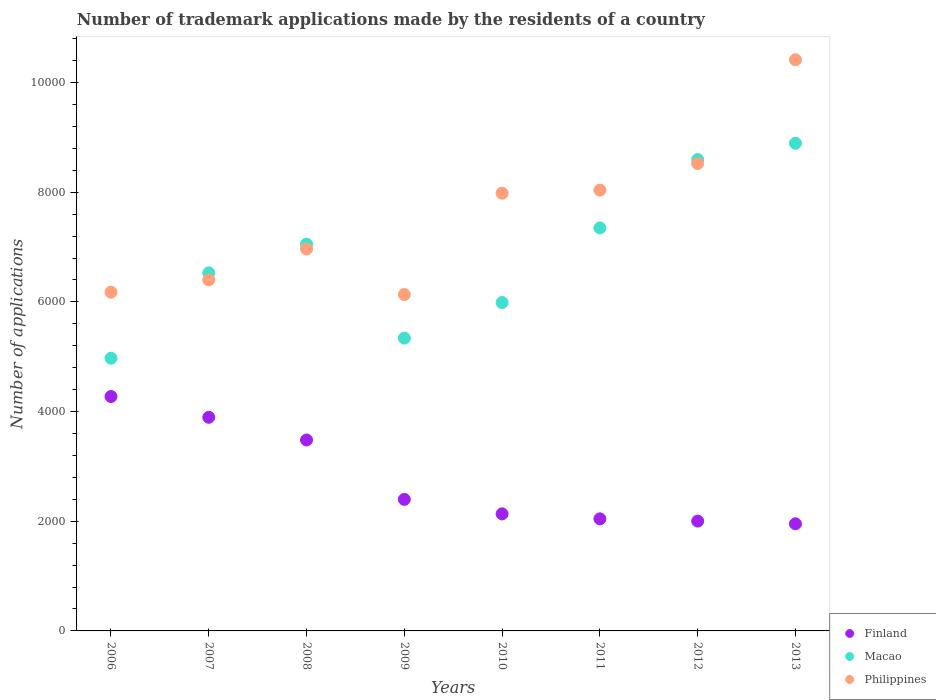Is the number of dotlines equal to the number of legend labels?
Offer a terse response. Yes. What is the number of trademark applications made by the residents in Finland in 2012?
Your response must be concise. 2003. Across all years, what is the maximum number of trademark applications made by the residents in Philippines?
Make the answer very short. 1.04e+04. Across all years, what is the minimum number of trademark applications made by the residents in Philippines?
Your answer should be very brief. 6135. What is the total number of trademark applications made by the residents in Finland in the graph?
Give a very brief answer. 2.22e+04. What is the difference between the number of trademark applications made by the residents in Macao in 2007 and that in 2010?
Give a very brief answer. 540. What is the difference between the number of trademark applications made by the residents in Philippines in 2008 and the number of trademark applications made by the residents in Macao in 2012?
Give a very brief answer. -1631. What is the average number of trademark applications made by the residents in Macao per year?
Provide a short and direct response. 6840.5. In the year 2007, what is the difference between the number of trademark applications made by the residents in Macao and number of trademark applications made by the residents in Philippines?
Make the answer very short. 127. In how many years, is the number of trademark applications made by the residents in Macao greater than 4800?
Your answer should be very brief. 8. What is the ratio of the number of trademark applications made by the residents in Finland in 2007 to that in 2012?
Make the answer very short. 1.95. Is the number of trademark applications made by the residents in Finland in 2006 less than that in 2009?
Provide a succinct answer. No. Is the difference between the number of trademark applications made by the residents in Macao in 2006 and 2012 greater than the difference between the number of trademark applications made by the residents in Philippines in 2006 and 2012?
Your answer should be compact. No. What is the difference between the highest and the second highest number of trademark applications made by the residents in Finland?
Ensure brevity in your answer.  379. What is the difference between the highest and the lowest number of trademark applications made by the residents in Finland?
Offer a terse response. 2321. In how many years, is the number of trademark applications made by the residents in Macao greater than the average number of trademark applications made by the residents in Macao taken over all years?
Ensure brevity in your answer.  4. Is it the case that in every year, the sum of the number of trademark applications made by the residents in Macao and number of trademark applications made by the residents in Philippines  is greater than the number of trademark applications made by the residents in Finland?
Your response must be concise. Yes. Does the number of trademark applications made by the residents in Philippines monotonically increase over the years?
Ensure brevity in your answer.  No. Is the number of trademark applications made by the residents in Philippines strictly less than the number of trademark applications made by the residents in Macao over the years?
Your response must be concise. No. How many dotlines are there?
Your answer should be very brief. 3. How many years are there in the graph?
Make the answer very short. 8. What is the difference between two consecutive major ticks on the Y-axis?
Offer a terse response. 2000. Are the values on the major ticks of Y-axis written in scientific E-notation?
Your answer should be very brief. No. How many legend labels are there?
Offer a terse response. 3. What is the title of the graph?
Offer a very short reply. Number of trademark applications made by the residents of a country. What is the label or title of the Y-axis?
Offer a terse response. Number of applications. What is the Number of applications of Finland in 2006?
Offer a terse response. 4275. What is the Number of applications in Macao in 2006?
Provide a succinct answer. 4973. What is the Number of applications of Philippines in 2006?
Provide a short and direct response. 6177. What is the Number of applications in Finland in 2007?
Your answer should be very brief. 3896. What is the Number of applications of Macao in 2007?
Keep it short and to the point. 6529. What is the Number of applications in Philippines in 2007?
Offer a very short reply. 6402. What is the Number of applications of Finland in 2008?
Provide a short and direct response. 3482. What is the Number of applications of Macao in 2008?
Keep it short and to the point. 7054. What is the Number of applications of Philippines in 2008?
Offer a terse response. 6965. What is the Number of applications of Finland in 2009?
Offer a terse response. 2399. What is the Number of applications of Macao in 2009?
Give a very brief answer. 5340. What is the Number of applications of Philippines in 2009?
Your response must be concise. 6135. What is the Number of applications in Finland in 2010?
Keep it short and to the point. 2135. What is the Number of applications in Macao in 2010?
Offer a terse response. 5989. What is the Number of applications in Philippines in 2010?
Give a very brief answer. 7983. What is the Number of applications in Finland in 2011?
Offer a terse response. 2044. What is the Number of applications of Macao in 2011?
Your response must be concise. 7350. What is the Number of applications in Philippines in 2011?
Ensure brevity in your answer.  8039. What is the Number of applications in Finland in 2012?
Provide a short and direct response. 2003. What is the Number of applications of Macao in 2012?
Your answer should be compact. 8596. What is the Number of applications in Philippines in 2012?
Offer a terse response. 8523. What is the Number of applications of Finland in 2013?
Provide a short and direct response. 1954. What is the Number of applications in Macao in 2013?
Your answer should be very brief. 8893. What is the Number of applications in Philippines in 2013?
Your answer should be very brief. 1.04e+04. Across all years, what is the maximum Number of applications in Finland?
Make the answer very short. 4275. Across all years, what is the maximum Number of applications in Macao?
Offer a terse response. 8893. Across all years, what is the maximum Number of applications in Philippines?
Make the answer very short. 1.04e+04. Across all years, what is the minimum Number of applications in Finland?
Give a very brief answer. 1954. Across all years, what is the minimum Number of applications in Macao?
Offer a terse response. 4973. Across all years, what is the minimum Number of applications of Philippines?
Ensure brevity in your answer.  6135. What is the total Number of applications in Finland in the graph?
Give a very brief answer. 2.22e+04. What is the total Number of applications in Macao in the graph?
Offer a terse response. 5.47e+04. What is the total Number of applications in Philippines in the graph?
Provide a short and direct response. 6.06e+04. What is the difference between the Number of applications of Finland in 2006 and that in 2007?
Keep it short and to the point. 379. What is the difference between the Number of applications of Macao in 2006 and that in 2007?
Make the answer very short. -1556. What is the difference between the Number of applications in Philippines in 2006 and that in 2007?
Offer a very short reply. -225. What is the difference between the Number of applications of Finland in 2006 and that in 2008?
Keep it short and to the point. 793. What is the difference between the Number of applications of Macao in 2006 and that in 2008?
Ensure brevity in your answer.  -2081. What is the difference between the Number of applications in Philippines in 2006 and that in 2008?
Keep it short and to the point. -788. What is the difference between the Number of applications of Finland in 2006 and that in 2009?
Keep it short and to the point. 1876. What is the difference between the Number of applications of Macao in 2006 and that in 2009?
Offer a terse response. -367. What is the difference between the Number of applications in Philippines in 2006 and that in 2009?
Ensure brevity in your answer.  42. What is the difference between the Number of applications of Finland in 2006 and that in 2010?
Your response must be concise. 2140. What is the difference between the Number of applications of Macao in 2006 and that in 2010?
Your answer should be compact. -1016. What is the difference between the Number of applications of Philippines in 2006 and that in 2010?
Make the answer very short. -1806. What is the difference between the Number of applications of Finland in 2006 and that in 2011?
Your response must be concise. 2231. What is the difference between the Number of applications of Macao in 2006 and that in 2011?
Ensure brevity in your answer.  -2377. What is the difference between the Number of applications of Philippines in 2006 and that in 2011?
Provide a succinct answer. -1862. What is the difference between the Number of applications in Finland in 2006 and that in 2012?
Provide a succinct answer. 2272. What is the difference between the Number of applications in Macao in 2006 and that in 2012?
Your answer should be compact. -3623. What is the difference between the Number of applications in Philippines in 2006 and that in 2012?
Your answer should be very brief. -2346. What is the difference between the Number of applications of Finland in 2006 and that in 2013?
Keep it short and to the point. 2321. What is the difference between the Number of applications of Macao in 2006 and that in 2013?
Your answer should be very brief. -3920. What is the difference between the Number of applications of Philippines in 2006 and that in 2013?
Give a very brief answer. -4239. What is the difference between the Number of applications of Finland in 2007 and that in 2008?
Ensure brevity in your answer.  414. What is the difference between the Number of applications in Macao in 2007 and that in 2008?
Your response must be concise. -525. What is the difference between the Number of applications of Philippines in 2007 and that in 2008?
Offer a very short reply. -563. What is the difference between the Number of applications of Finland in 2007 and that in 2009?
Provide a short and direct response. 1497. What is the difference between the Number of applications in Macao in 2007 and that in 2009?
Make the answer very short. 1189. What is the difference between the Number of applications of Philippines in 2007 and that in 2009?
Offer a terse response. 267. What is the difference between the Number of applications in Finland in 2007 and that in 2010?
Provide a short and direct response. 1761. What is the difference between the Number of applications of Macao in 2007 and that in 2010?
Your answer should be compact. 540. What is the difference between the Number of applications of Philippines in 2007 and that in 2010?
Your answer should be compact. -1581. What is the difference between the Number of applications of Finland in 2007 and that in 2011?
Your response must be concise. 1852. What is the difference between the Number of applications in Macao in 2007 and that in 2011?
Give a very brief answer. -821. What is the difference between the Number of applications of Philippines in 2007 and that in 2011?
Give a very brief answer. -1637. What is the difference between the Number of applications of Finland in 2007 and that in 2012?
Offer a terse response. 1893. What is the difference between the Number of applications in Macao in 2007 and that in 2012?
Offer a terse response. -2067. What is the difference between the Number of applications of Philippines in 2007 and that in 2012?
Offer a terse response. -2121. What is the difference between the Number of applications of Finland in 2007 and that in 2013?
Your answer should be compact. 1942. What is the difference between the Number of applications of Macao in 2007 and that in 2013?
Your answer should be compact. -2364. What is the difference between the Number of applications in Philippines in 2007 and that in 2013?
Offer a terse response. -4014. What is the difference between the Number of applications of Finland in 2008 and that in 2009?
Your answer should be compact. 1083. What is the difference between the Number of applications in Macao in 2008 and that in 2009?
Offer a very short reply. 1714. What is the difference between the Number of applications in Philippines in 2008 and that in 2009?
Make the answer very short. 830. What is the difference between the Number of applications of Finland in 2008 and that in 2010?
Offer a very short reply. 1347. What is the difference between the Number of applications of Macao in 2008 and that in 2010?
Keep it short and to the point. 1065. What is the difference between the Number of applications of Philippines in 2008 and that in 2010?
Your answer should be very brief. -1018. What is the difference between the Number of applications in Finland in 2008 and that in 2011?
Provide a short and direct response. 1438. What is the difference between the Number of applications of Macao in 2008 and that in 2011?
Provide a short and direct response. -296. What is the difference between the Number of applications in Philippines in 2008 and that in 2011?
Provide a succinct answer. -1074. What is the difference between the Number of applications in Finland in 2008 and that in 2012?
Your response must be concise. 1479. What is the difference between the Number of applications of Macao in 2008 and that in 2012?
Provide a short and direct response. -1542. What is the difference between the Number of applications of Philippines in 2008 and that in 2012?
Provide a short and direct response. -1558. What is the difference between the Number of applications of Finland in 2008 and that in 2013?
Offer a terse response. 1528. What is the difference between the Number of applications in Macao in 2008 and that in 2013?
Your answer should be compact. -1839. What is the difference between the Number of applications of Philippines in 2008 and that in 2013?
Offer a very short reply. -3451. What is the difference between the Number of applications in Finland in 2009 and that in 2010?
Provide a succinct answer. 264. What is the difference between the Number of applications in Macao in 2009 and that in 2010?
Provide a succinct answer. -649. What is the difference between the Number of applications of Philippines in 2009 and that in 2010?
Offer a very short reply. -1848. What is the difference between the Number of applications in Finland in 2009 and that in 2011?
Provide a short and direct response. 355. What is the difference between the Number of applications in Macao in 2009 and that in 2011?
Your response must be concise. -2010. What is the difference between the Number of applications of Philippines in 2009 and that in 2011?
Offer a terse response. -1904. What is the difference between the Number of applications in Finland in 2009 and that in 2012?
Offer a very short reply. 396. What is the difference between the Number of applications in Macao in 2009 and that in 2012?
Provide a short and direct response. -3256. What is the difference between the Number of applications of Philippines in 2009 and that in 2012?
Keep it short and to the point. -2388. What is the difference between the Number of applications in Finland in 2009 and that in 2013?
Your answer should be very brief. 445. What is the difference between the Number of applications in Macao in 2009 and that in 2013?
Your answer should be compact. -3553. What is the difference between the Number of applications in Philippines in 2009 and that in 2013?
Provide a succinct answer. -4281. What is the difference between the Number of applications in Finland in 2010 and that in 2011?
Your answer should be compact. 91. What is the difference between the Number of applications in Macao in 2010 and that in 2011?
Offer a terse response. -1361. What is the difference between the Number of applications of Philippines in 2010 and that in 2011?
Provide a succinct answer. -56. What is the difference between the Number of applications in Finland in 2010 and that in 2012?
Ensure brevity in your answer.  132. What is the difference between the Number of applications in Macao in 2010 and that in 2012?
Give a very brief answer. -2607. What is the difference between the Number of applications in Philippines in 2010 and that in 2012?
Provide a short and direct response. -540. What is the difference between the Number of applications of Finland in 2010 and that in 2013?
Your response must be concise. 181. What is the difference between the Number of applications in Macao in 2010 and that in 2013?
Give a very brief answer. -2904. What is the difference between the Number of applications in Philippines in 2010 and that in 2013?
Make the answer very short. -2433. What is the difference between the Number of applications of Macao in 2011 and that in 2012?
Give a very brief answer. -1246. What is the difference between the Number of applications of Philippines in 2011 and that in 2012?
Your answer should be very brief. -484. What is the difference between the Number of applications in Macao in 2011 and that in 2013?
Provide a succinct answer. -1543. What is the difference between the Number of applications in Philippines in 2011 and that in 2013?
Give a very brief answer. -2377. What is the difference between the Number of applications of Finland in 2012 and that in 2013?
Your answer should be compact. 49. What is the difference between the Number of applications in Macao in 2012 and that in 2013?
Your answer should be compact. -297. What is the difference between the Number of applications of Philippines in 2012 and that in 2013?
Ensure brevity in your answer.  -1893. What is the difference between the Number of applications of Finland in 2006 and the Number of applications of Macao in 2007?
Make the answer very short. -2254. What is the difference between the Number of applications in Finland in 2006 and the Number of applications in Philippines in 2007?
Offer a terse response. -2127. What is the difference between the Number of applications of Macao in 2006 and the Number of applications of Philippines in 2007?
Provide a succinct answer. -1429. What is the difference between the Number of applications of Finland in 2006 and the Number of applications of Macao in 2008?
Offer a terse response. -2779. What is the difference between the Number of applications of Finland in 2006 and the Number of applications of Philippines in 2008?
Make the answer very short. -2690. What is the difference between the Number of applications of Macao in 2006 and the Number of applications of Philippines in 2008?
Your answer should be compact. -1992. What is the difference between the Number of applications of Finland in 2006 and the Number of applications of Macao in 2009?
Offer a terse response. -1065. What is the difference between the Number of applications of Finland in 2006 and the Number of applications of Philippines in 2009?
Provide a short and direct response. -1860. What is the difference between the Number of applications in Macao in 2006 and the Number of applications in Philippines in 2009?
Provide a short and direct response. -1162. What is the difference between the Number of applications in Finland in 2006 and the Number of applications in Macao in 2010?
Provide a short and direct response. -1714. What is the difference between the Number of applications of Finland in 2006 and the Number of applications of Philippines in 2010?
Provide a succinct answer. -3708. What is the difference between the Number of applications of Macao in 2006 and the Number of applications of Philippines in 2010?
Ensure brevity in your answer.  -3010. What is the difference between the Number of applications of Finland in 2006 and the Number of applications of Macao in 2011?
Provide a succinct answer. -3075. What is the difference between the Number of applications in Finland in 2006 and the Number of applications in Philippines in 2011?
Provide a short and direct response. -3764. What is the difference between the Number of applications of Macao in 2006 and the Number of applications of Philippines in 2011?
Give a very brief answer. -3066. What is the difference between the Number of applications in Finland in 2006 and the Number of applications in Macao in 2012?
Your answer should be compact. -4321. What is the difference between the Number of applications of Finland in 2006 and the Number of applications of Philippines in 2012?
Ensure brevity in your answer.  -4248. What is the difference between the Number of applications of Macao in 2006 and the Number of applications of Philippines in 2012?
Provide a short and direct response. -3550. What is the difference between the Number of applications of Finland in 2006 and the Number of applications of Macao in 2013?
Your answer should be compact. -4618. What is the difference between the Number of applications of Finland in 2006 and the Number of applications of Philippines in 2013?
Give a very brief answer. -6141. What is the difference between the Number of applications of Macao in 2006 and the Number of applications of Philippines in 2013?
Your response must be concise. -5443. What is the difference between the Number of applications of Finland in 2007 and the Number of applications of Macao in 2008?
Your answer should be very brief. -3158. What is the difference between the Number of applications of Finland in 2007 and the Number of applications of Philippines in 2008?
Your answer should be compact. -3069. What is the difference between the Number of applications of Macao in 2007 and the Number of applications of Philippines in 2008?
Your answer should be compact. -436. What is the difference between the Number of applications in Finland in 2007 and the Number of applications in Macao in 2009?
Offer a very short reply. -1444. What is the difference between the Number of applications in Finland in 2007 and the Number of applications in Philippines in 2009?
Your answer should be very brief. -2239. What is the difference between the Number of applications in Macao in 2007 and the Number of applications in Philippines in 2009?
Your response must be concise. 394. What is the difference between the Number of applications of Finland in 2007 and the Number of applications of Macao in 2010?
Your response must be concise. -2093. What is the difference between the Number of applications in Finland in 2007 and the Number of applications in Philippines in 2010?
Ensure brevity in your answer.  -4087. What is the difference between the Number of applications of Macao in 2007 and the Number of applications of Philippines in 2010?
Provide a succinct answer. -1454. What is the difference between the Number of applications in Finland in 2007 and the Number of applications in Macao in 2011?
Ensure brevity in your answer.  -3454. What is the difference between the Number of applications in Finland in 2007 and the Number of applications in Philippines in 2011?
Your answer should be very brief. -4143. What is the difference between the Number of applications of Macao in 2007 and the Number of applications of Philippines in 2011?
Your answer should be very brief. -1510. What is the difference between the Number of applications of Finland in 2007 and the Number of applications of Macao in 2012?
Make the answer very short. -4700. What is the difference between the Number of applications of Finland in 2007 and the Number of applications of Philippines in 2012?
Offer a terse response. -4627. What is the difference between the Number of applications in Macao in 2007 and the Number of applications in Philippines in 2012?
Your answer should be very brief. -1994. What is the difference between the Number of applications of Finland in 2007 and the Number of applications of Macao in 2013?
Make the answer very short. -4997. What is the difference between the Number of applications of Finland in 2007 and the Number of applications of Philippines in 2013?
Ensure brevity in your answer.  -6520. What is the difference between the Number of applications in Macao in 2007 and the Number of applications in Philippines in 2013?
Your response must be concise. -3887. What is the difference between the Number of applications in Finland in 2008 and the Number of applications in Macao in 2009?
Your answer should be very brief. -1858. What is the difference between the Number of applications in Finland in 2008 and the Number of applications in Philippines in 2009?
Your answer should be very brief. -2653. What is the difference between the Number of applications in Macao in 2008 and the Number of applications in Philippines in 2009?
Offer a terse response. 919. What is the difference between the Number of applications in Finland in 2008 and the Number of applications in Macao in 2010?
Give a very brief answer. -2507. What is the difference between the Number of applications of Finland in 2008 and the Number of applications of Philippines in 2010?
Give a very brief answer. -4501. What is the difference between the Number of applications in Macao in 2008 and the Number of applications in Philippines in 2010?
Give a very brief answer. -929. What is the difference between the Number of applications in Finland in 2008 and the Number of applications in Macao in 2011?
Your answer should be very brief. -3868. What is the difference between the Number of applications in Finland in 2008 and the Number of applications in Philippines in 2011?
Make the answer very short. -4557. What is the difference between the Number of applications in Macao in 2008 and the Number of applications in Philippines in 2011?
Offer a very short reply. -985. What is the difference between the Number of applications in Finland in 2008 and the Number of applications in Macao in 2012?
Give a very brief answer. -5114. What is the difference between the Number of applications of Finland in 2008 and the Number of applications of Philippines in 2012?
Ensure brevity in your answer.  -5041. What is the difference between the Number of applications in Macao in 2008 and the Number of applications in Philippines in 2012?
Make the answer very short. -1469. What is the difference between the Number of applications in Finland in 2008 and the Number of applications in Macao in 2013?
Provide a short and direct response. -5411. What is the difference between the Number of applications in Finland in 2008 and the Number of applications in Philippines in 2013?
Keep it short and to the point. -6934. What is the difference between the Number of applications of Macao in 2008 and the Number of applications of Philippines in 2013?
Make the answer very short. -3362. What is the difference between the Number of applications in Finland in 2009 and the Number of applications in Macao in 2010?
Your answer should be very brief. -3590. What is the difference between the Number of applications in Finland in 2009 and the Number of applications in Philippines in 2010?
Keep it short and to the point. -5584. What is the difference between the Number of applications of Macao in 2009 and the Number of applications of Philippines in 2010?
Keep it short and to the point. -2643. What is the difference between the Number of applications in Finland in 2009 and the Number of applications in Macao in 2011?
Provide a succinct answer. -4951. What is the difference between the Number of applications of Finland in 2009 and the Number of applications of Philippines in 2011?
Provide a succinct answer. -5640. What is the difference between the Number of applications of Macao in 2009 and the Number of applications of Philippines in 2011?
Ensure brevity in your answer.  -2699. What is the difference between the Number of applications of Finland in 2009 and the Number of applications of Macao in 2012?
Offer a very short reply. -6197. What is the difference between the Number of applications in Finland in 2009 and the Number of applications in Philippines in 2012?
Ensure brevity in your answer.  -6124. What is the difference between the Number of applications of Macao in 2009 and the Number of applications of Philippines in 2012?
Make the answer very short. -3183. What is the difference between the Number of applications in Finland in 2009 and the Number of applications in Macao in 2013?
Provide a short and direct response. -6494. What is the difference between the Number of applications in Finland in 2009 and the Number of applications in Philippines in 2013?
Provide a succinct answer. -8017. What is the difference between the Number of applications of Macao in 2009 and the Number of applications of Philippines in 2013?
Offer a terse response. -5076. What is the difference between the Number of applications of Finland in 2010 and the Number of applications of Macao in 2011?
Provide a succinct answer. -5215. What is the difference between the Number of applications in Finland in 2010 and the Number of applications in Philippines in 2011?
Make the answer very short. -5904. What is the difference between the Number of applications in Macao in 2010 and the Number of applications in Philippines in 2011?
Make the answer very short. -2050. What is the difference between the Number of applications of Finland in 2010 and the Number of applications of Macao in 2012?
Ensure brevity in your answer.  -6461. What is the difference between the Number of applications of Finland in 2010 and the Number of applications of Philippines in 2012?
Your response must be concise. -6388. What is the difference between the Number of applications of Macao in 2010 and the Number of applications of Philippines in 2012?
Ensure brevity in your answer.  -2534. What is the difference between the Number of applications in Finland in 2010 and the Number of applications in Macao in 2013?
Keep it short and to the point. -6758. What is the difference between the Number of applications of Finland in 2010 and the Number of applications of Philippines in 2013?
Make the answer very short. -8281. What is the difference between the Number of applications in Macao in 2010 and the Number of applications in Philippines in 2013?
Provide a short and direct response. -4427. What is the difference between the Number of applications in Finland in 2011 and the Number of applications in Macao in 2012?
Provide a succinct answer. -6552. What is the difference between the Number of applications in Finland in 2011 and the Number of applications in Philippines in 2012?
Ensure brevity in your answer.  -6479. What is the difference between the Number of applications in Macao in 2011 and the Number of applications in Philippines in 2012?
Ensure brevity in your answer.  -1173. What is the difference between the Number of applications in Finland in 2011 and the Number of applications in Macao in 2013?
Your response must be concise. -6849. What is the difference between the Number of applications in Finland in 2011 and the Number of applications in Philippines in 2013?
Keep it short and to the point. -8372. What is the difference between the Number of applications in Macao in 2011 and the Number of applications in Philippines in 2013?
Your answer should be very brief. -3066. What is the difference between the Number of applications of Finland in 2012 and the Number of applications of Macao in 2013?
Your answer should be very brief. -6890. What is the difference between the Number of applications of Finland in 2012 and the Number of applications of Philippines in 2013?
Your response must be concise. -8413. What is the difference between the Number of applications in Macao in 2012 and the Number of applications in Philippines in 2013?
Make the answer very short. -1820. What is the average Number of applications of Finland per year?
Keep it short and to the point. 2773.5. What is the average Number of applications of Macao per year?
Your answer should be compact. 6840.5. What is the average Number of applications of Philippines per year?
Offer a very short reply. 7580. In the year 2006, what is the difference between the Number of applications in Finland and Number of applications in Macao?
Keep it short and to the point. -698. In the year 2006, what is the difference between the Number of applications of Finland and Number of applications of Philippines?
Your answer should be very brief. -1902. In the year 2006, what is the difference between the Number of applications of Macao and Number of applications of Philippines?
Offer a terse response. -1204. In the year 2007, what is the difference between the Number of applications of Finland and Number of applications of Macao?
Give a very brief answer. -2633. In the year 2007, what is the difference between the Number of applications in Finland and Number of applications in Philippines?
Make the answer very short. -2506. In the year 2007, what is the difference between the Number of applications in Macao and Number of applications in Philippines?
Make the answer very short. 127. In the year 2008, what is the difference between the Number of applications of Finland and Number of applications of Macao?
Your answer should be compact. -3572. In the year 2008, what is the difference between the Number of applications in Finland and Number of applications in Philippines?
Offer a terse response. -3483. In the year 2008, what is the difference between the Number of applications in Macao and Number of applications in Philippines?
Provide a succinct answer. 89. In the year 2009, what is the difference between the Number of applications in Finland and Number of applications in Macao?
Your response must be concise. -2941. In the year 2009, what is the difference between the Number of applications in Finland and Number of applications in Philippines?
Offer a terse response. -3736. In the year 2009, what is the difference between the Number of applications of Macao and Number of applications of Philippines?
Offer a terse response. -795. In the year 2010, what is the difference between the Number of applications of Finland and Number of applications of Macao?
Provide a short and direct response. -3854. In the year 2010, what is the difference between the Number of applications in Finland and Number of applications in Philippines?
Offer a terse response. -5848. In the year 2010, what is the difference between the Number of applications in Macao and Number of applications in Philippines?
Ensure brevity in your answer.  -1994. In the year 2011, what is the difference between the Number of applications in Finland and Number of applications in Macao?
Your response must be concise. -5306. In the year 2011, what is the difference between the Number of applications of Finland and Number of applications of Philippines?
Provide a succinct answer. -5995. In the year 2011, what is the difference between the Number of applications in Macao and Number of applications in Philippines?
Ensure brevity in your answer.  -689. In the year 2012, what is the difference between the Number of applications of Finland and Number of applications of Macao?
Keep it short and to the point. -6593. In the year 2012, what is the difference between the Number of applications in Finland and Number of applications in Philippines?
Provide a succinct answer. -6520. In the year 2013, what is the difference between the Number of applications in Finland and Number of applications in Macao?
Ensure brevity in your answer.  -6939. In the year 2013, what is the difference between the Number of applications in Finland and Number of applications in Philippines?
Your response must be concise. -8462. In the year 2013, what is the difference between the Number of applications in Macao and Number of applications in Philippines?
Your response must be concise. -1523. What is the ratio of the Number of applications of Finland in 2006 to that in 2007?
Make the answer very short. 1.1. What is the ratio of the Number of applications in Macao in 2006 to that in 2007?
Ensure brevity in your answer.  0.76. What is the ratio of the Number of applications in Philippines in 2006 to that in 2007?
Your response must be concise. 0.96. What is the ratio of the Number of applications of Finland in 2006 to that in 2008?
Offer a very short reply. 1.23. What is the ratio of the Number of applications of Macao in 2006 to that in 2008?
Keep it short and to the point. 0.7. What is the ratio of the Number of applications of Philippines in 2006 to that in 2008?
Give a very brief answer. 0.89. What is the ratio of the Number of applications in Finland in 2006 to that in 2009?
Make the answer very short. 1.78. What is the ratio of the Number of applications of Macao in 2006 to that in 2009?
Your answer should be compact. 0.93. What is the ratio of the Number of applications of Philippines in 2006 to that in 2009?
Make the answer very short. 1.01. What is the ratio of the Number of applications in Finland in 2006 to that in 2010?
Your answer should be compact. 2. What is the ratio of the Number of applications in Macao in 2006 to that in 2010?
Give a very brief answer. 0.83. What is the ratio of the Number of applications of Philippines in 2006 to that in 2010?
Your answer should be very brief. 0.77. What is the ratio of the Number of applications in Finland in 2006 to that in 2011?
Your answer should be compact. 2.09. What is the ratio of the Number of applications of Macao in 2006 to that in 2011?
Provide a short and direct response. 0.68. What is the ratio of the Number of applications in Philippines in 2006 to that in 2011?
Give a very brief answer. 0.77. What is the ratio of the Number of applications in Finland in 2006 to that in 2012?
Provide a short and direct response. 2.13. What is the ratio of the Number of applications of Macao in 2006 to that in 2012?
Ensure brevity in your answer.  0.58. What is the ratio of the Number of applications of Philippines in 2006 to that in 2012?
Provide a succinct answer. 0.72. What is the ratio of the Number of applications of Finland in 2006 to that in 2013?
Your answer should be very brief. 2.19. What is the ratio of the Number of applications in Macao in 2006 to that in 2013?
Offer a very short reply. 0.56. What is the ratio of the Number of applications of Philippines in 2006 to that in 2013?
Your response must be concise. 0.59. What is the ratio of the Number of applications in Finland in 2007 to that in 2008?
Keep it short and to the point. 1.12. What is the ratio of the Number of applications in Macao in 2007 to that in 2008?
Ensure brevity in your answer.  0.93. What is the ratio of the Number of applications of Philippines in 2007 to that in 2008?
Offer a very short reply. 0.92. What is the ratio of the Number of applications of Finland in 2007 to that in 2009?
Your answer should be very brief. 1.62. What is the ratio of the Number of applications in Macao in 2007 to that in 2009?
Your answer should be very brief. 1.22. What is the ratio of the Number of applications of Philippines in 2007 to that in 2009?
Make the answer very short. 1.04. What is the ratio of the Number of applications in Finland in 2007 to that in 2010?
Offer a very short reply. 1.82. What is the ratio of the Number of applications in Macao in 2007 to that in 2010?
Your response must be concise. 1.09. What is the ratio of the Number of applications of Philippines in 2007 to that in 2010?
Offer a terse response. 0.8. What is the ratio of the Number of applications of Finland in 2007 to that in 2011?
Offer a very short reply. 1.91. What is the ratio of the Number of applications of Macao in 2007 to that in 2011?
Give a very brief answer. 0.89. What is the ratio of the Number of applications in Philippines in 2007 to that in 2011?
Your answer should be very brief. 0.8. What is the ratio of the Number of applications of Finland in 2007 to that in 2012?
Provide a succinct answer. 1.95. What is the ratio of the Number of applications of Macao in 2007 to that in 2012?
Provide a short and direct response. 0.76. What is the ratio of the Number of applications of Philippines in 2007 to that in 2012?
Give a very brief answer. 0.75. What is the ratio of the Number of applications in Finland in 2007 to that in 2013?
Keep it short and to the point. 1.99. What is the ratio of the Number of applications in Macao in 2007 to that in 2013?
Ensure brevity in your answer.  0.73. What is the ratio of the Number of applications of Philippines in 2007 to that in 2013?
Give a very brief answer. 0.61. What is the ratio of the Number of applications in Finland in 2008 to that in 2009?
Keep it short and to the point. 1.45. What is the ratio of the Number of applications in Macao in 2008 to that in 2009?
Make the answer very short. 1.32. What is the ratio of the Number of applications in Philippines in 2008 to that in 2009?
Provide a short and direct response. 1.14. What is the ratio of the Number of applications in Finland in 2008 to that in 2010?
Give a very brief answer. 1.63. What is the ratio of the Number of applications in Macao in 2008 to that in 2010?
Provide a short and direct response. 1.18. What is the ratio of the Number of applications in Philippines in 2008 to that in 2010?
Make the answer very short. 0.87. What is the ratio of the Number of applications in Finland in 2008 to that in 2011?
Provide a succinct answer. 1.7. What is the ratio of the Number of applications of Macao in 2008 to that in 2011?
Give a very brief answer. 0.96. What is the ratio of the Number of applications in Philippines in 2008 to that in 2011?
Your answer should be very brief. 0.87. What is the ratio of the Number of applications in Finland in 2008 to that in 2012?
Your response must be concise. 1.74. What is the ratio of the Number of applications of Macao in 2008 to that in 2012?
Your response must be concise. 0.82. What is the ratio of the Number of applications in Philippines in 2008 to that in 2012?
Your answer should be compact. 0.82. What is the ratio of the Number of applications in Finland in 2008 to that in 2013?
Offer a very short reply. 1.78. What is the ratio of the Number of applications of Macao in 2008 to that in 2013?
Offer a terse response. 0.79. What is the ratio of the Number of applications in Philippines in 2008 to that in 2013?
Offer a terse response. 0.67. What is the ratio of the Number of applications in Finland in 2009 to that in 2010?
Provide a succinct answer. 1.12. What is the ratio of the Number of applications in Macao in 2009 to that in 2010?
Provide a short and direct response. 0.89. What is the ratio of the Number of applications in Philippines in 2009 to that in 2010?
Your answer should be compact. 0.77. What is the ratio of the Number of applications of Finland in 2009 to that in 2011?
Offer a terse response. 1.17. What is the ratio of the Number of applications in Macao in 2009 to that in 2011?
Offer a very short reply. 0.73. What is the ratio of the Number of applications of Philippines in 2009 to that in 2011?
Give a very brief answer. 0.76. What is the ratio of the Number of applications of Finland in 2009 to that in 2012?
Your answer should be compact. 1.2. What is the ratio of the Number of applications of Macao in 2009 to that in 2012?
Your response must be concise. 0.62. What is the ratio of the Number of applications of Philippines in 2009 to that in 2012?
Offer a very short reply. 0.72. What is the ratio of the Number of applications in Finland in 2009 to that in 2013?
Offer a very short reply. 1.23. What is the ratio of the Number of applications in Macao in 2009 to that in 2013?
Your answer should be compact. 0.6. What is the ratio of the Number of applications of Philippines in 2009 to that in 2013?
Provide a short and direct response. 0.59. What is the ratio of the Number of applications in Finland in 2010 to that in 2011?
Your answer should be very brief. 1.04. What is the ratio of the Number of applications of Macao in 2010 to that in 2011?
Make the answer very short. 0.81. What is the ratio of the Number of applications in Philippines in 2010 to that in 2011?
Offer a very short reply. 0.99. What is the ratio of the Number of applications in Finland in 2010 to that in 2012?
Provide a succinct answer. 1.07. What is the ratio of the Number of applications of Macao in 2010 to that in 2012?
Your response must be concise. 0.7. What is the ratio of the Number of applications of Philippines in 2010 to that in 2012?
Keep it short and to the point. 0.94. What is the ratio of the Number of applications in Finland in 2010 to that in 2013?
Make the answer very short. 1.09. What is the ratio of the Number of applications of Macao in 2010 to that in 2013?
Provide a succinct answer. 0.67. What is the ratio of the Number of applications of Philippines in 2010 to that in 2013?
Make the answer very short. 0.77. What is the ratio of the Number of applications in Finland in 2011 to that in 2012?
Your answer should be very brief. 1.02. What is the ratio of the Number of applications of Macao in 2011 to that in 2012?
Offer a very short reply. 0.85. What is the ratio of the Number of applications in Philippines in 2011 to that in 2012?
Ensure brevity in your answer.  0.94. What is the ratio of the Number of applications in Finland in 2011 to that in 2013?
Your answer should be compact. 1.05. What is the ratio of the Number of applications in Macao in 2011 to that in 2013?
Your answer should be very brief. 0.83. What is the ratio of the Number of applications in Philippines in 2011 to that in 2013?
Ensure brevity in your answer.  0.77. What is the ratio of the Number of applications in Finland in 2012 to that in 2013?
Keep it short and to the point. 1.03. What is the ratio of the Number of applications of Macao in 2012 to that in 2013?
Provide a short and direct response. 0.97. What is the ratio of the Number of applications of Philippines in 2012 to that in 2013?
Make the answer very short. 0.82. What is the difference between the highest and the second highest Number of applications in Finland?
Make the answer very short. 379. What is the difference between the highest and the second highest Number of applications in Macao?
Ensure brevity in your answer.  297. What is the difference between the highest and the second highest Number of applications of Philippines?
Make the answer very short. 1893. What is the difference between the highest and the lowest Number of applications of Finland?
Provide a short and direct response. 2321. What is the difference between the highest and the lowest Number of applications of Macao?
Keep it short and to the point. 3920. What is the difference between the highest and the lowest Number of applications of Philippines?
Ensure brevity in your answer.  4281. 